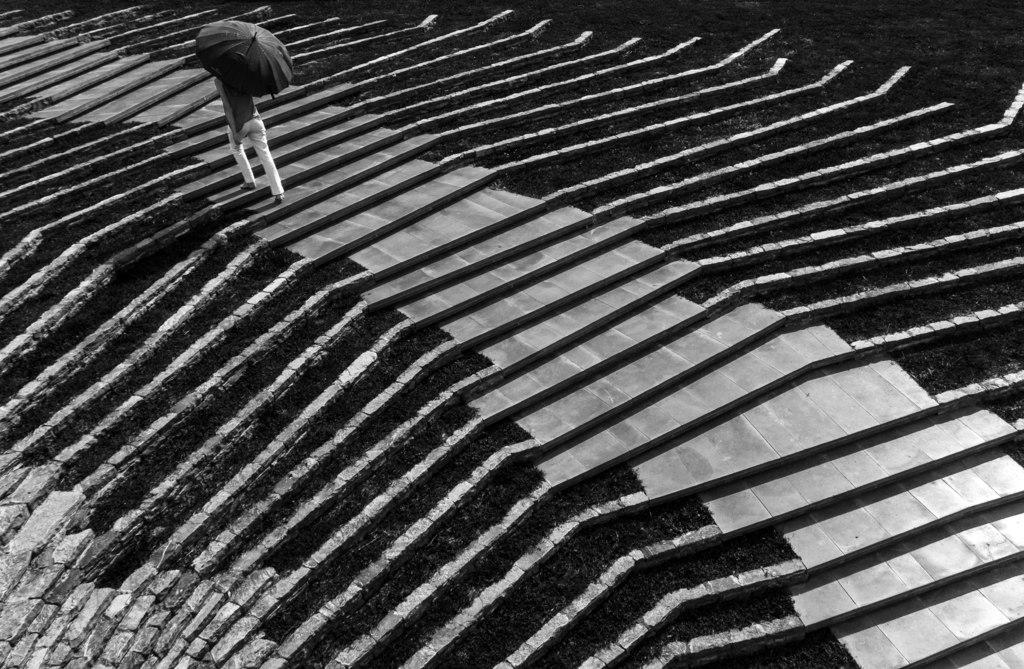Who or what is present in the image? There is a person in the image. What is the person holding in the image? The person is holding an umbrella. What activity is the person engaged in? The person is climbing stairs. What type of books can be seen on the person's head in the image? There are no books present in the image; the person is holding an umbrella and climbing stairs. 